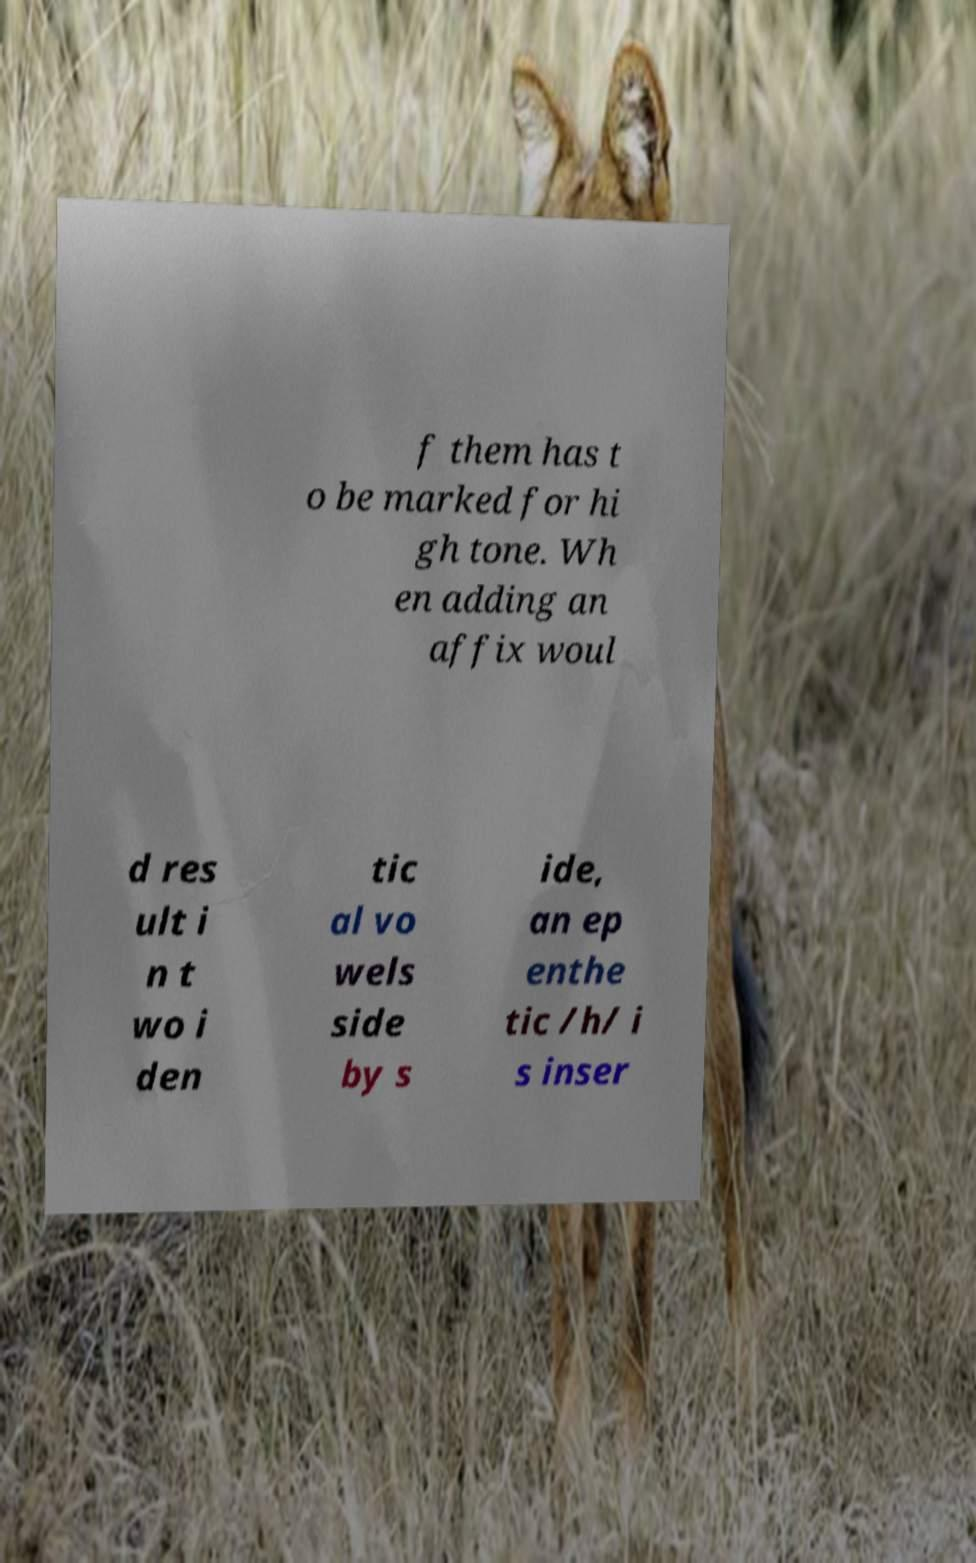Could you assist in decoding the text presented in this image and type it out clearly? f them has t o be marked for hi gh tone. Wh en adding an affix woul d res ult i n t wo i den tic al vo wels side by s ide, an ep enthe tic /h/ i s inser 